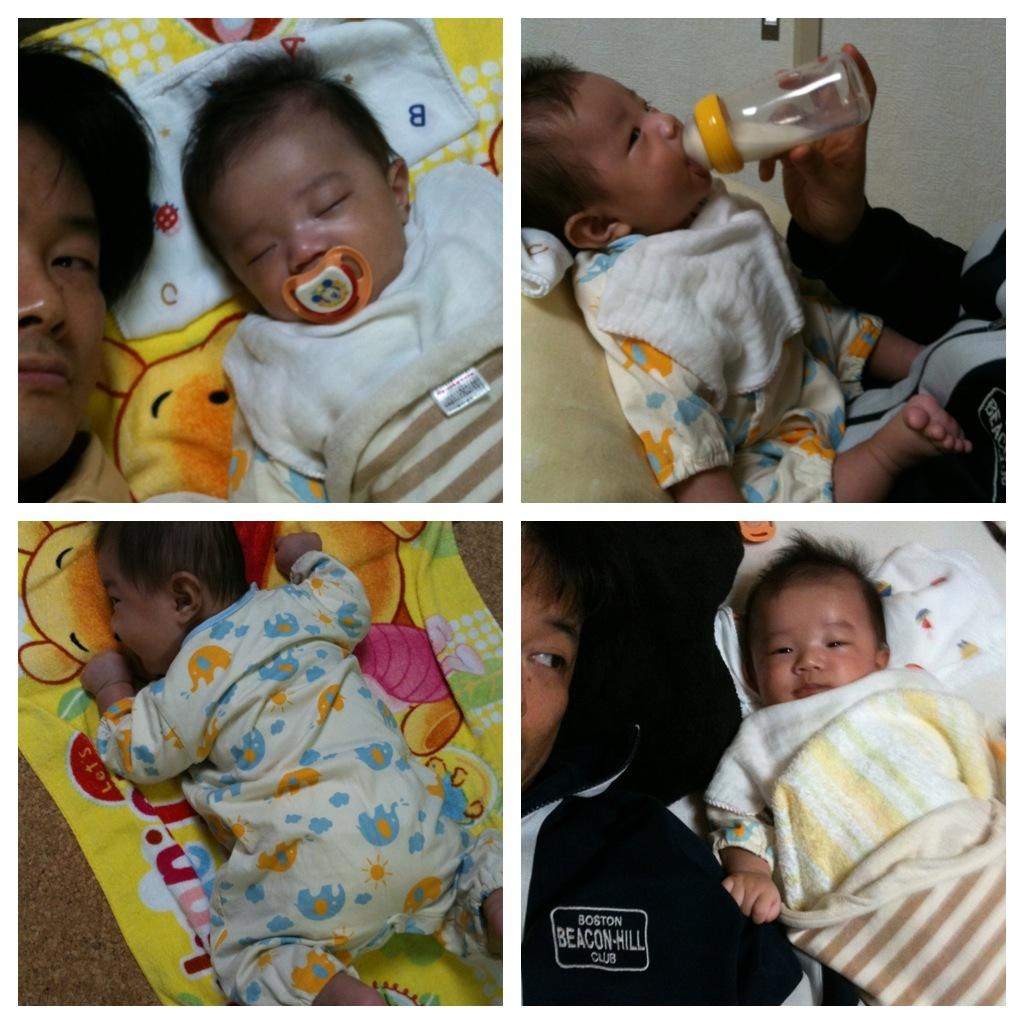What is the main subject of the image? The main subject of the image is a baby. What is the baby doing in the image? The baby is sleeping in a blanket and drinking milk. Where is the baby sleeping in the image? The baby is sleeping under a carpet. Are there any other people in the image? Yes, there is a person sleeping in the image. What type of receipt can be seen in the image? There is no receipt present in the image. Can you tell me how many buttons are on the baby's blanket? The provided facts do not mention any buttons on the baby's blanket. --- Facts: 1. There is a car in the image. 2. The car is parked on the street. 3. There are trees on both sides of the street. 4. The sky is visible in the image. 5. There is a traffic light in the image. Absurd Topics: bird, flower, bicycle Conversation: What is the main subject of the image? The main subject of the image is a car. Where is the car located in the image? The car is parked on the street. What can be seen on both sides of the street in the image? There are trees on both sides of the street. What is visible in the sky in the image? The sky is visible in the image. What traffic control device is present in the image? There is a traffic light in the image. Reasoning: Let's think step by step in order to produce the conversation. We start by identifying the main subject of the image, which is the car. Then, we describe the car's location and the surrounding environment, including the trees on both sides of the street and the visible sky. We also mention the presence of a traffic light in the image. Each question is designed to elicit a specific detail about the image that is known from the provided facts. Absurd Question/Answer: What type of bird can be seen sitting on the car's hood in the image? There is no bird present on the car's hood in the image. Can you tell me how many flowers are planted along the street in the image? The provided facts do not mention any flowers planted along the street. 